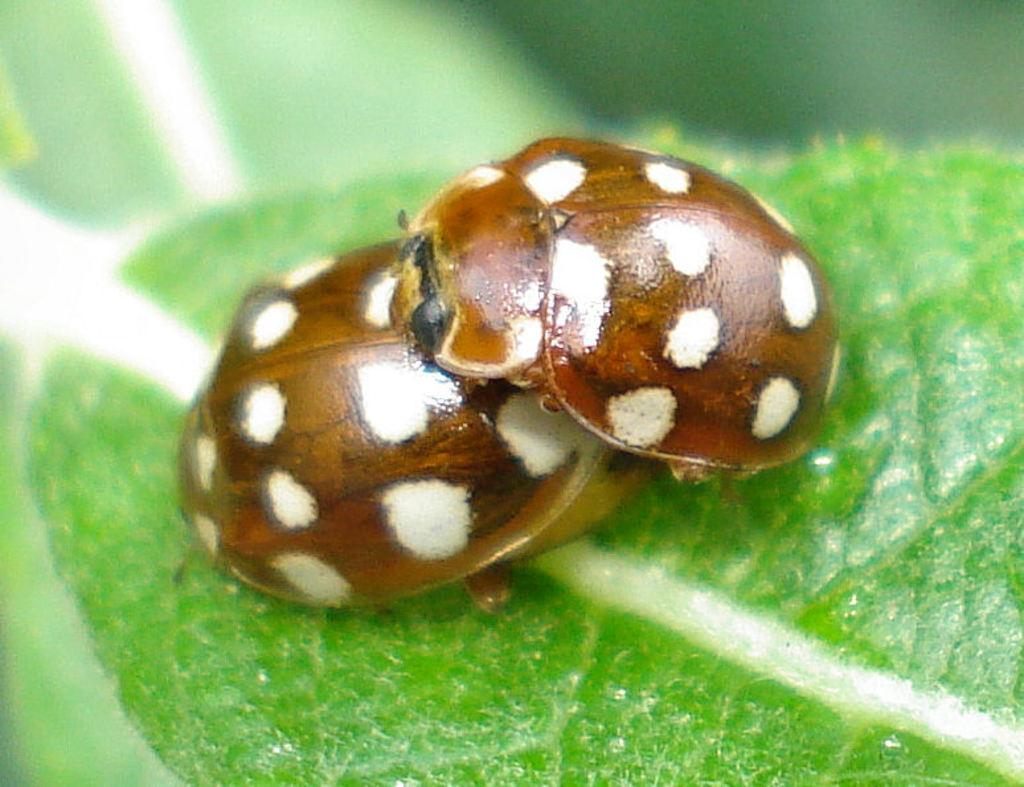What insects can be seen in the image? There are ladybugs on a leaf in the image. What is the primary focus of the image? The ladybugs on a leaf are the primary focus of the image. Can you describe the background of the image? The background of the image is blurred. How many times has the plant been folded in the image? There is no plant present in the image, and therefore it cannot be folded. 